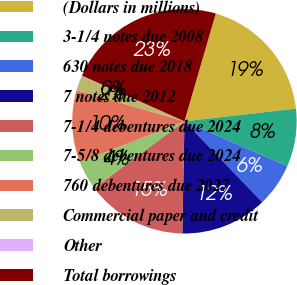Convert chart to OTSL. <chart><loc_0><loc_0><loc_500><loc_500><pie_chart><fcel>(Dollars in millions)<fcel>3-1/4 notes due 2008<fcel>630 notes due 2018<fcel>7 notes due 2012<fcel>7-1/4 debentures due 2024<fcel>7-5/8 debentures due 2024<fcel>760 debentures due 2027<fcel>Commercial paper and credit<fcel>Other<fcel>Total borrowings<nl><fcel>18.7%<fcel>8.34%<fcel>6.27%<fcel>12.49%<fcel>14.56%<fcel>4.2%<fcel>10.41%<fcel>2.13%<fcel>0.06%<fcel>22.84%<nl></chart> 